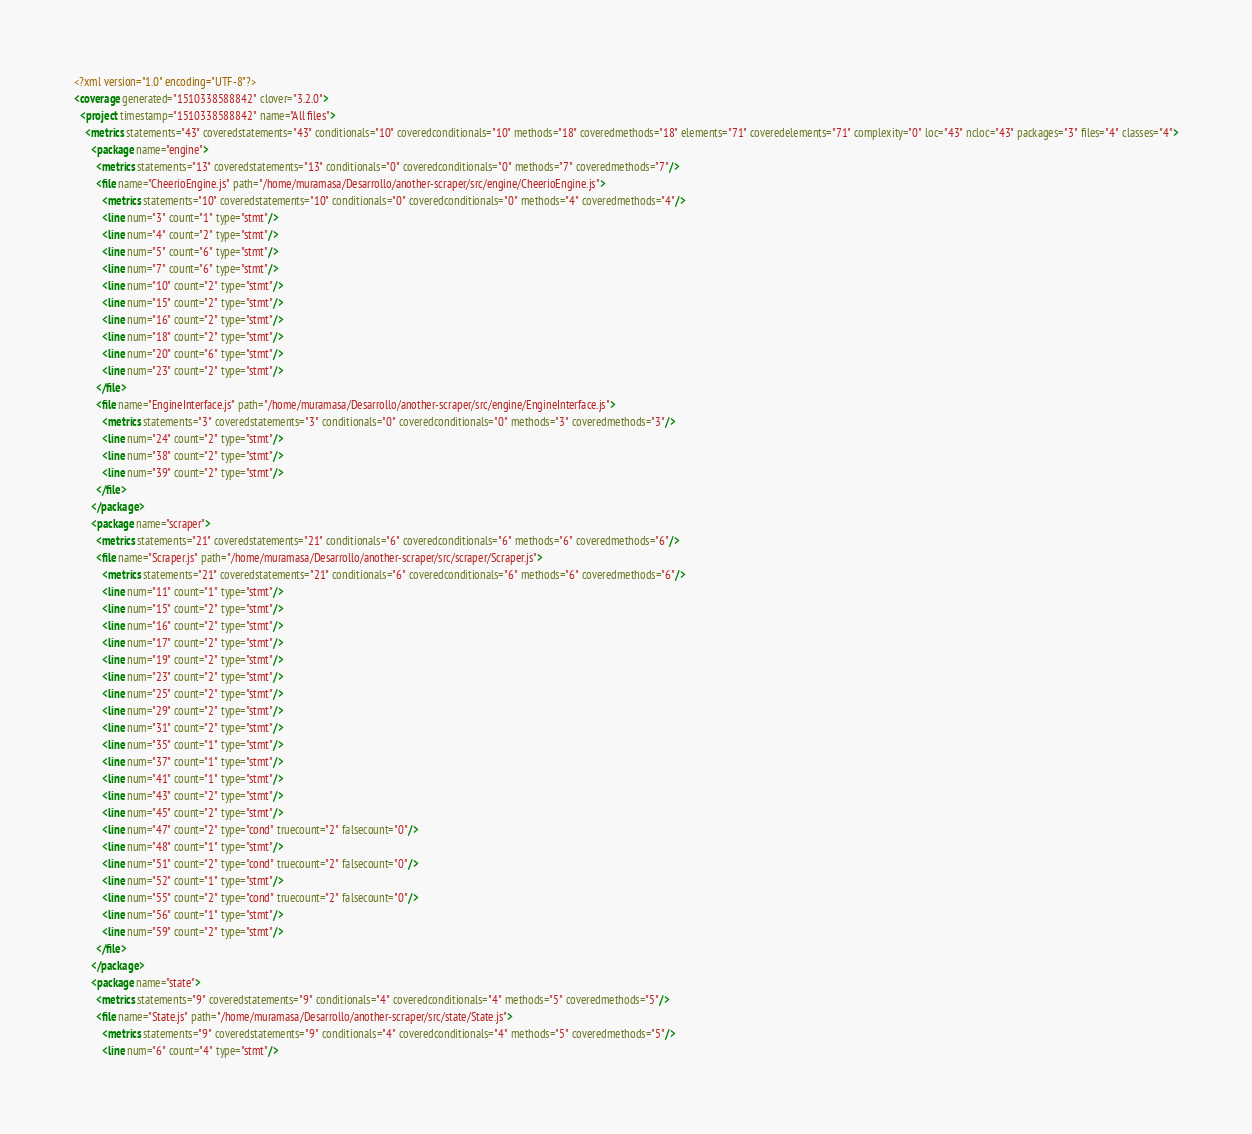<code> <loc_0><loc_0><loc_500><loc_500><_XML_><?xml version="1.0" encoding="UTF-8"?>
<coverage generated="1510338588842" clover="3.2.0">
  <project timestamp="1510338588842" name="All files">
    <metrics statements="43" coveredstatements="43" conditionals="10" coveredconditionals="10" methods="18" coveredmethods="18" elements="71" coveredelements="71" complexity="0" loc="43" ncloc="43" packages="3" files="4" classes="4">
      <package name="engine">
        <metrics statements="13" coveredstatements="13" conditionals="0" coveredconditionals="0" methods="7" coveredmethods="7"/>
        <file name="CheerioEngine.js" path="/home/muramasa/Desarrollo/another-scraper/src/engine/CheerioEngine.js">
          <metrics statements="10" coveredstatements="10" conditionals="0" coveredconditionals="0" methods="4" coveredmethods="4"/>
          <line num="3" count="1" type="stmt"/>
          <line num="4" count="2" type="stmt"/>
          <line num="5" count="6" type="stmt"/>
          <line num="7" count="6" type="stmt"/>
          <line num="10" count="2" type="stmt"/>
          <line num="15" count="2" type="stmt"/>
          <line num="16" count="2" type="stmt"/>
          <line num="18" count="2" type="stmt"/>
          <line num="20" count="6" type="stmt"/>
          <line num="23" count="2" type="stmt"/>
        </file>
        <file name="EngineInterface.js" path="/home/muramasa/Desarrollo/another-scraper/src/engine/EngineInterface.js">
          <metrics statements="3" coveredstatements="3" conditionals="0" coveredconditionals="0" methods="3" coveredmethods="3"/>
          <line num="24" count="2" type="stmt"/>
          <line num="38" count="2" type="stmt"/>
          <line num="39" count="2" type="stmt"/>
        </file>
      </package>
      <package name="scraper">
        <metrics statements="21" coveredstatements="21" conditionals="6" coveredconditionals="6" methods="6" coveredmethods="6"/>
        <file name="Scraper.js" path="/home/muramasa/Desarrollo/another-scraper/src/scraper/Scraper.js">
          <metrics statements="21" coveredstatements="21" conditionals="6" coveredconditionals="6" methods="6" coveredmethods="6"/>
          <line num="11" count="1" type="stmt"/>
          <line num="15" count="2" type="stmt"/>
          <line num="16" count="2" type="stmt"/>
          <line num="17" count="2" type="stmt"/>
          <line num="19" count="2" type="stmt"/>
          <line num="23" count="2" type="stmt"/>
          <line num="25" count="2" type="stmt"/>
          <line num="29" count="2" type="stmt"/>
          <line num="31" count="2" type="stmt"/>
          <line num="35" count="1" type="stmt"/>
          <line num="37" count="1" type="stmt"/>
          <line num="41" count="1" type="stmt"/>
          <line num="43" count="2" type="stmt"/>
          <line num="45" count="2" type="stmt"/>
          <line num="47" count="2" type="cond" truecount="2" falsecount="0"/>
          <line num="48" count="1" type="stmt"/>
          <line num="51" count="2" type="cond" truecount="2" falsecount="0"/>
          <line num="52" count="1" type="stmt"/>
          <line num="55" count="2" type="cond" truecount="2" falsecount="0"/>
          <line num="56" count="1" type="stmt"/>
          <line num="59" count="2" type="stmt"/>
        </file>
      </package>
      <package name="state">
        <metrics statements="9" coveredstatements="9" conditionals="4" coveredconditionals="4" methods="5" coveredmethods="5"/>
        <file name="State.js" path="/home/muramasa/Desarrollo/another-scraper/src/state/State.js">
          <metrics statements="9" coveredstatements="9" conditionals="4" coveredconditionals="4" methods="5" coveredmethods="5"/>
          <line num="6" count="4" type="stmt"/></code> 